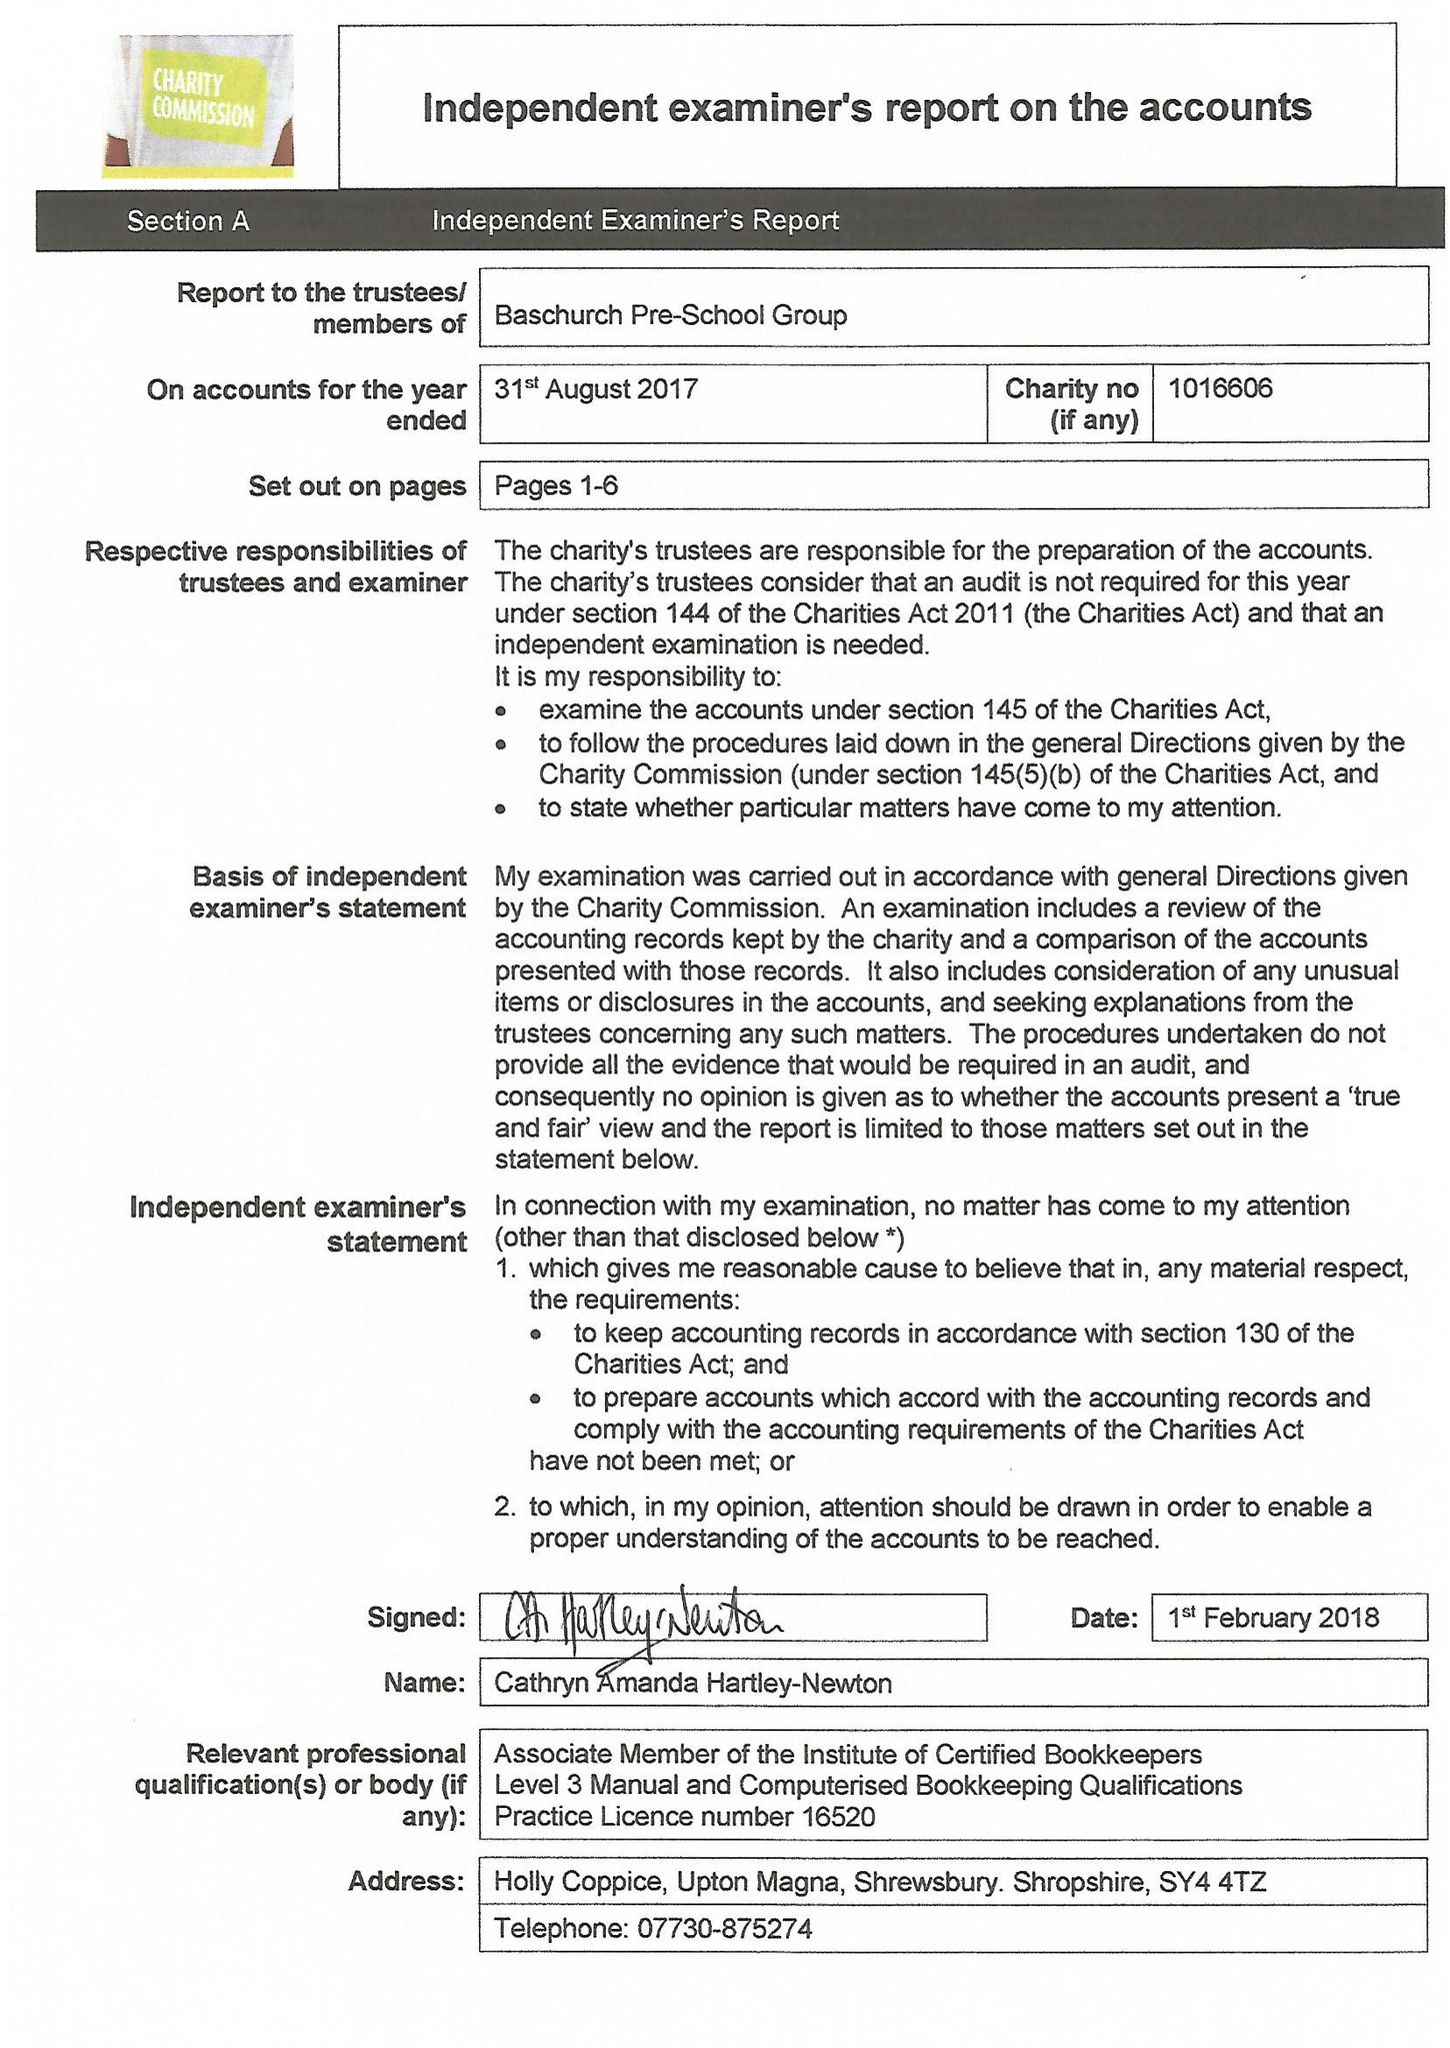What is the value for the address__street_line?
Answer the question using a single word or phrase. None 